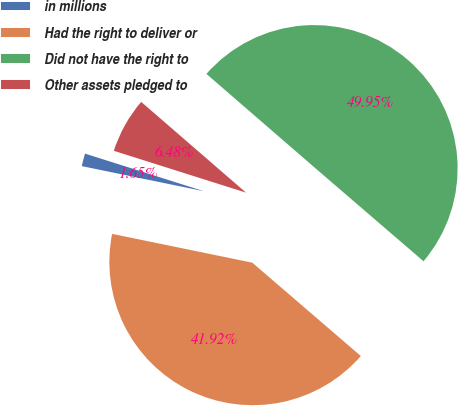<chart> <loc_0><loc_0><loc_500><loc_500><pie_chart><fcel>in millions<fcel>Had the right to deliver or<fcel>Did not have the right to<fcel>Other assets pledged to<nl><fcel>1.65%<fcel>41.92%<fcel>49.95%<fcel>6.48%<nl></chart> 